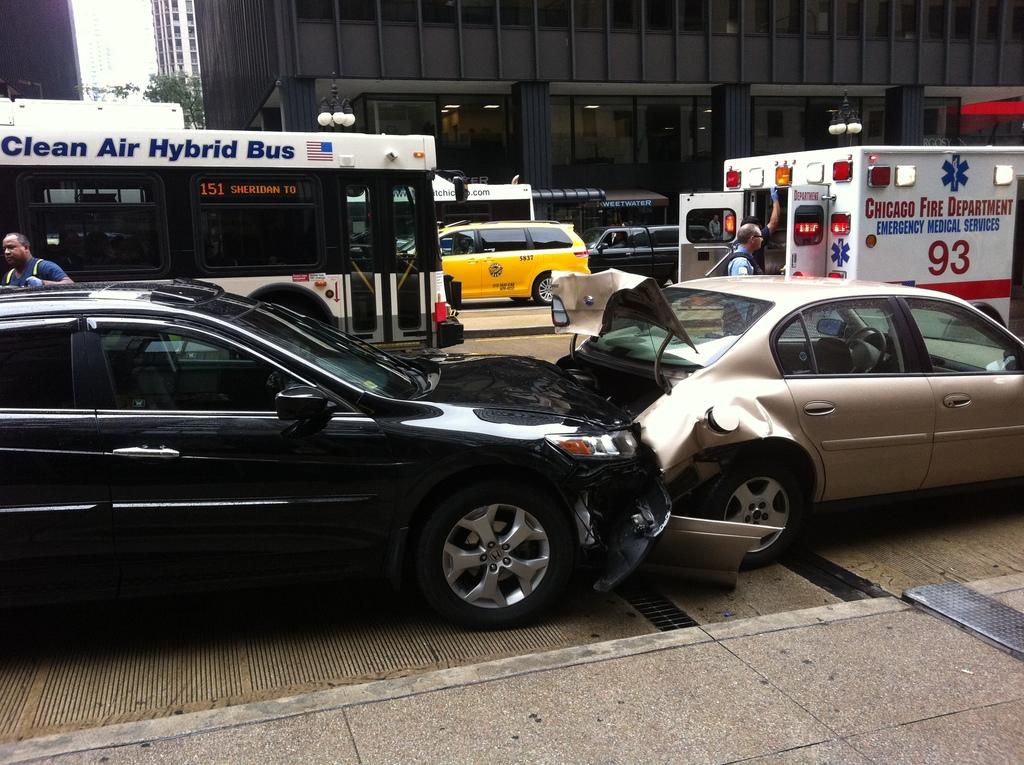How is the bus cleaner for the air than a normal bus?
Your answer should be compact. Hybrid. How does a hybrid bus work?
Make the answer very short. Answering does not require reading text in the image. 